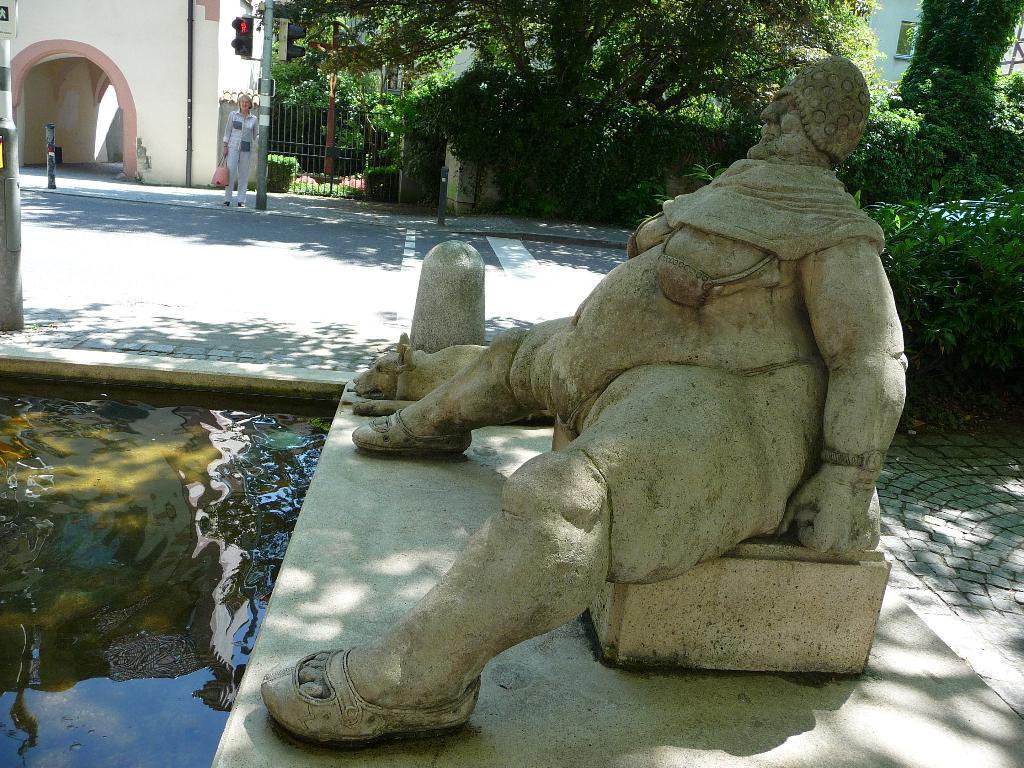Could you give a brief overview of what you see in this image? In this image I can see a statue of a person and a dog and in front of the statues there is water. In the background I can see the road and there is a woman holding bag and standing on a footpath and there is a pole beside the woman and a building and there are lots of plants and trees. 